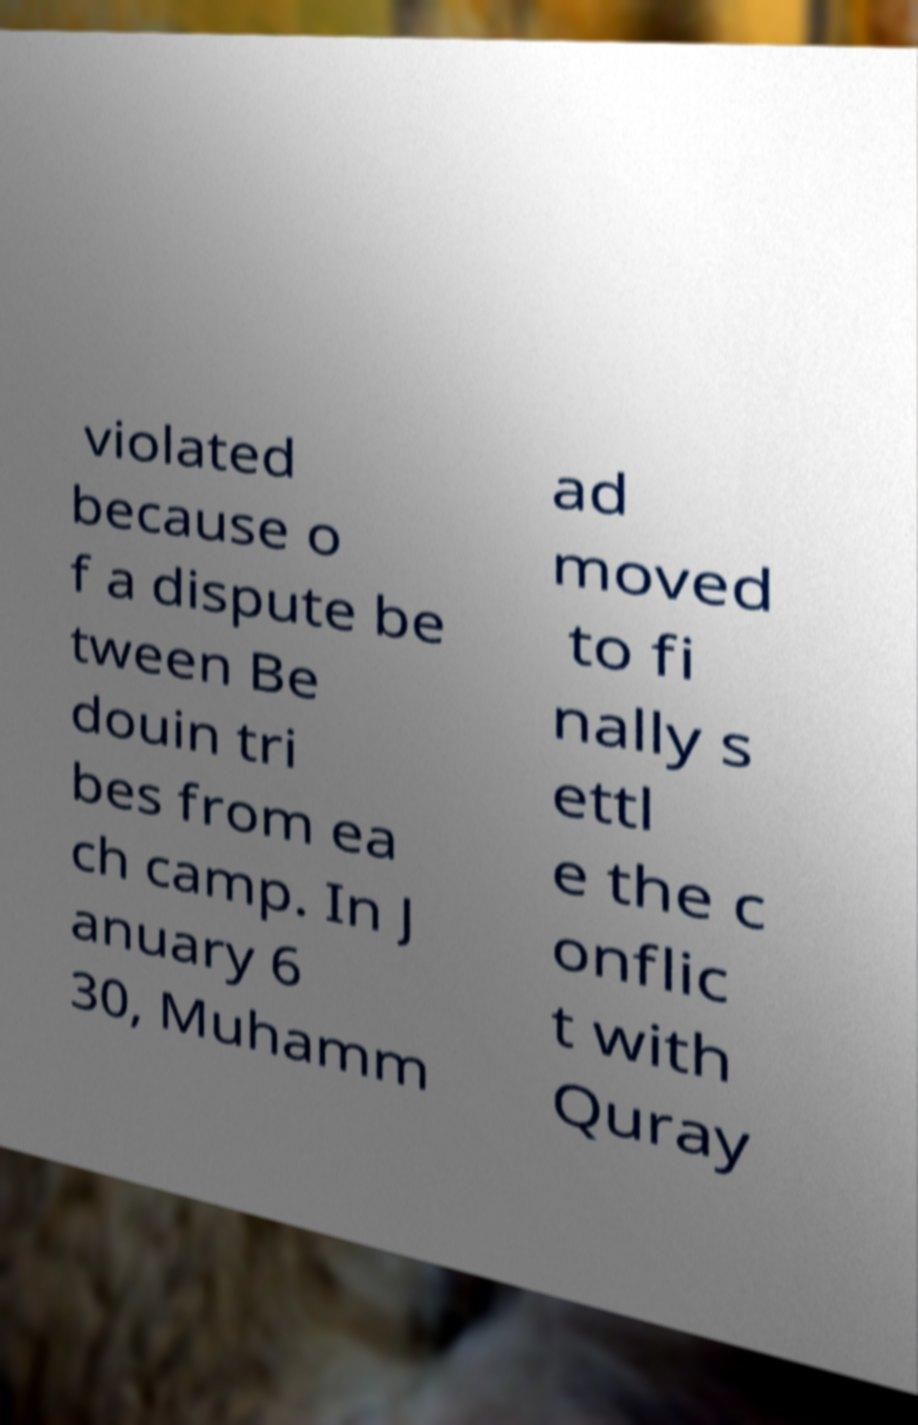Can you accurately transcribe the text from the provided image for me? violated because o f a dispute be tween Be douin tri bes from ea ch camp. In J anuary 6 30, Muhamm ad moved to fi nally s ettl e the c onflic t with Quray 